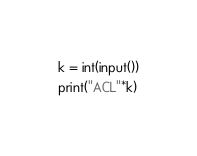Convert code to text. <code><loc_0><loc_0><loc_500><loc_500><_Python_>k = int(input())
print("ACL"*k)
</code> 